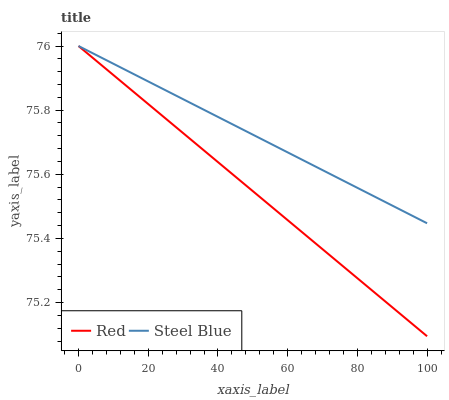Does Red have the minimum area under the curve?
Answer yes or no. Yes. Does Steel Blue have the maximum area under the curve?
Answer yes or no. Yes. Does Red have the maximum area under the curve?
Answer yes or no. No. Is Red the smoothest?
Answer yes or no. Yes. Is Steel Blue the roughest?
Answer yes or no. Yes. Is Red the roughest?
Answer yes or no. No. Does Red have the lowest value?
Answer yes or no. Yes. Does Red have the highest value?
Answer yes or no. Yes. Does Red intersect Steel Blue?
Answer yes or no. Yes. Is Red less than Steel Blue?
Answer yes or no. No. Is Red greater than Steel Blue?
Answer yes or no. No. 